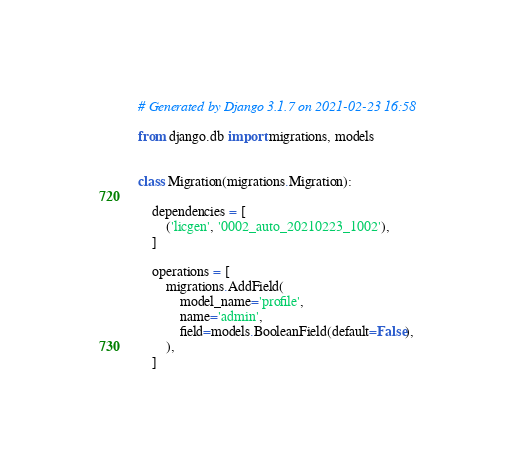Convert code to text. <code><loc_0><loc_0><loc_500><loc_500><_Python_># Generated by Django 3.1.7 on 2021-02-23 16:58

from django.db import migrations, models


class Migration(migrations.Migration):

    dependencies = [
        ('licgen', '0002_auto_20210223_1002'),
    ]

    operations = [
        migrations.AddField(
            model_name='profile',
            name='admin',
            field=models.BooleanField(default=False),
        ),
    ]
</code> 